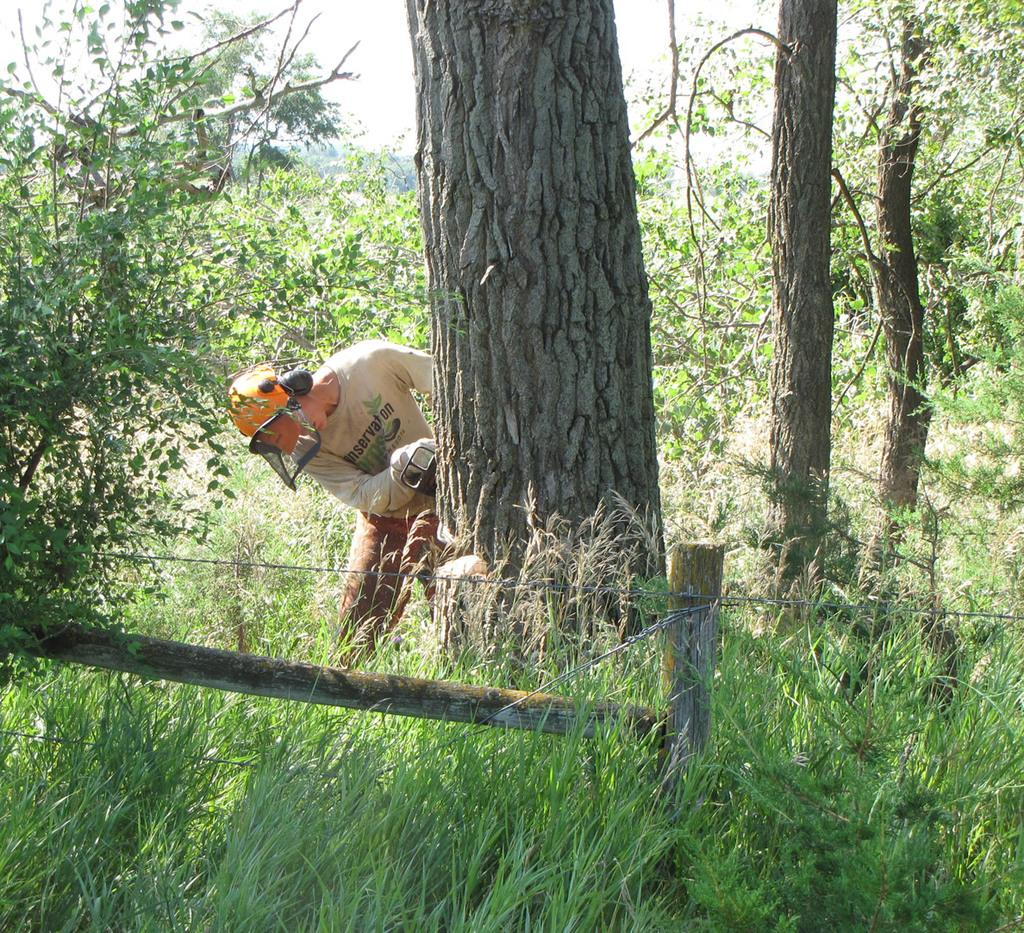What can be seen in the image? There is a person in the image. What is the person holding? The person is holding something. What protective gear is the person wearing? The person is wearing a helmet. What type of natural environment is visible in the image? There are trees and grass in the image. What architectural feature can be seen in the image? There is fencing in the image. What is the color of the sky in the image? The sky is white in color. What is the person's tendency to avoid death in the image? There is no information about the person's tendency to avoid death in the image. How many fingers can be seen on the person's hand in the image? The image does not show the person's fingers, so it cannot be determined how many fingers are visible. 